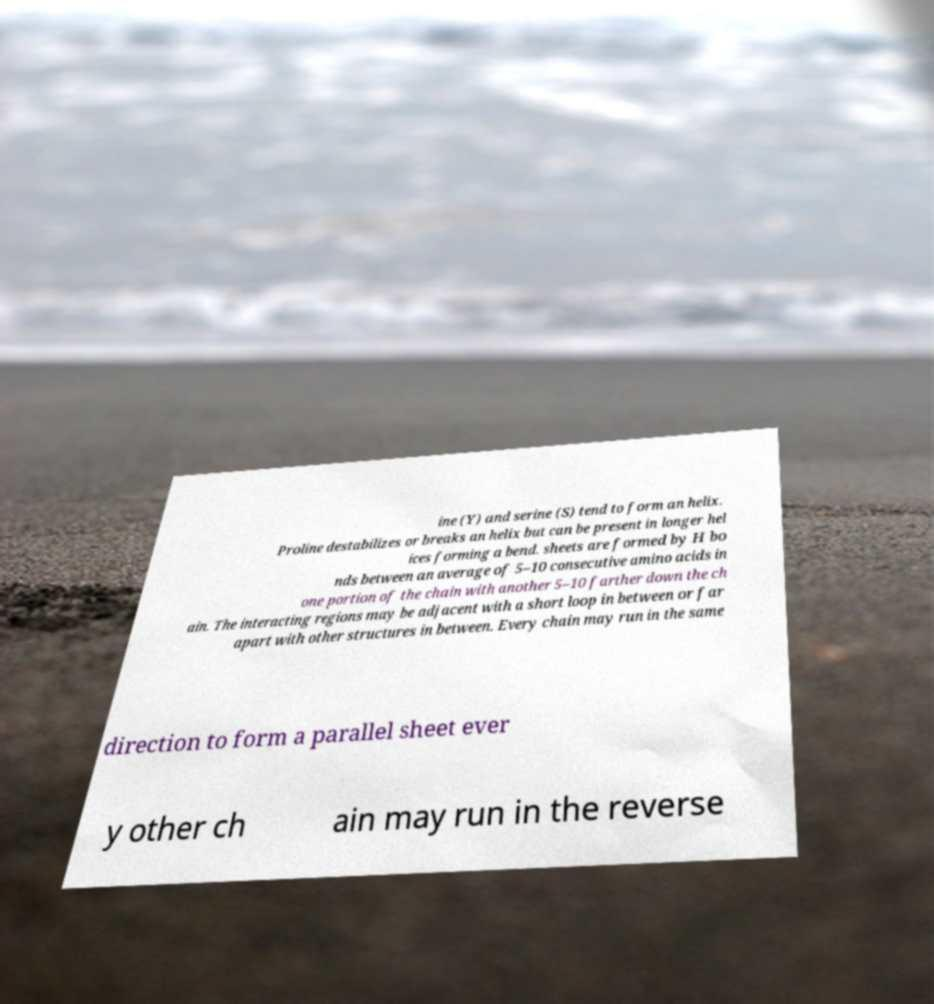Could you assist in decoding the text presented in this image and type it out clearly? ine (Y) and serine (S) tend to form an helix. Proline destabilizes or breaks an helix but can be present in longer hel ices forming a bend. sheets are formed by H bo nds between an average of 5–10 consecutive amino acids in one portion of the chain with another 5–10 farther down the ch ain. The interacting regions may be adjacent with a short loop in between or far apart with other structures in between. Every chain may run in the same direction to form a parallel sheet ever y other ch ain may run in the reverse 